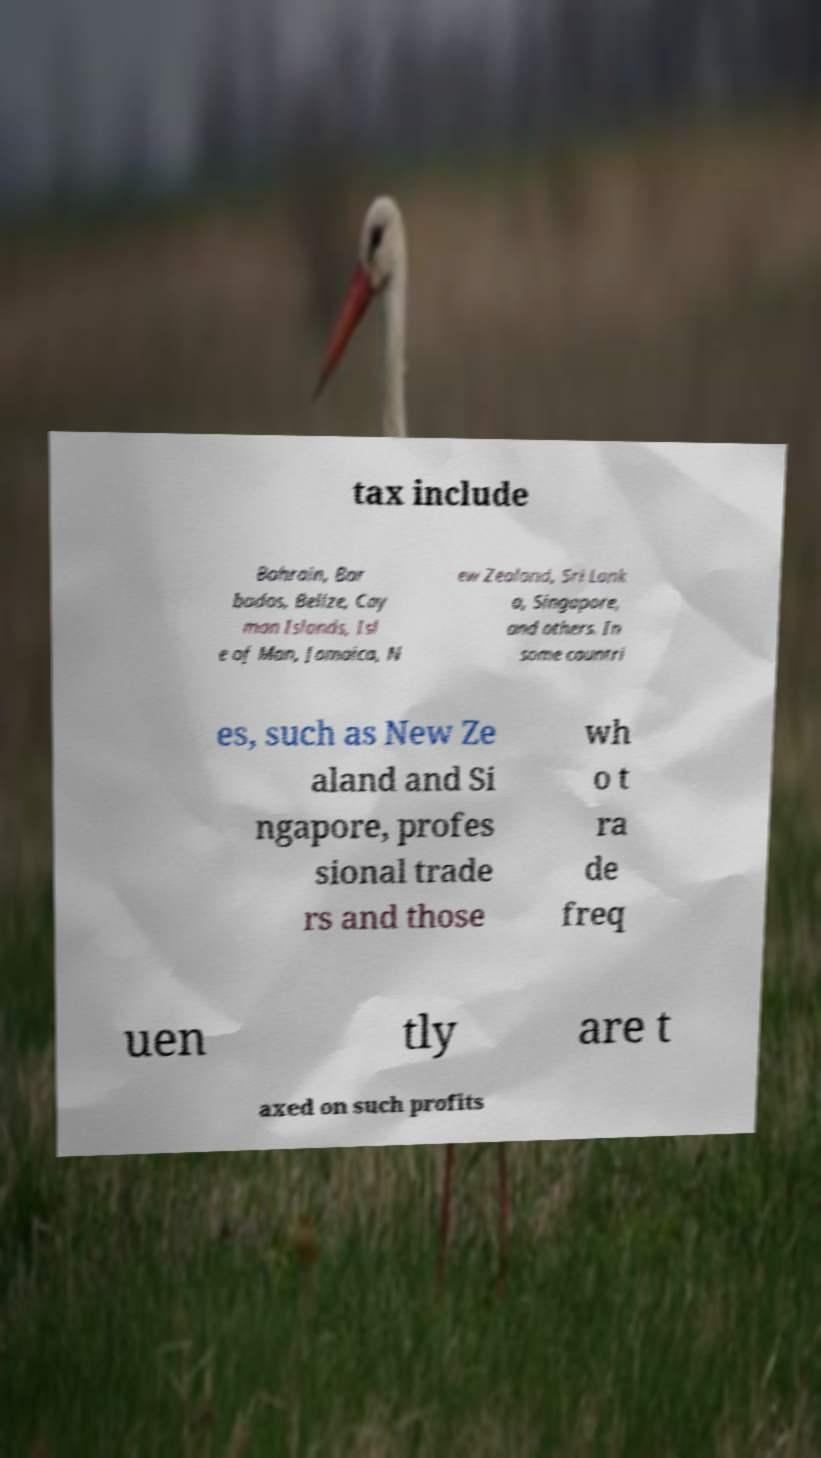I need the written content from this picture converted into text. Can you do that? tax include Bahrain, Bar bados, Belize, Cay man Islands, Isl e of Man, Jamaica, N ew Zealand, Sri Lank a, Singapore, and others. In some countri es, such as New Ze aland and Si ngapore, profes sional trade rs and those wh o t ra de freq uen tly are t axed on such profits 